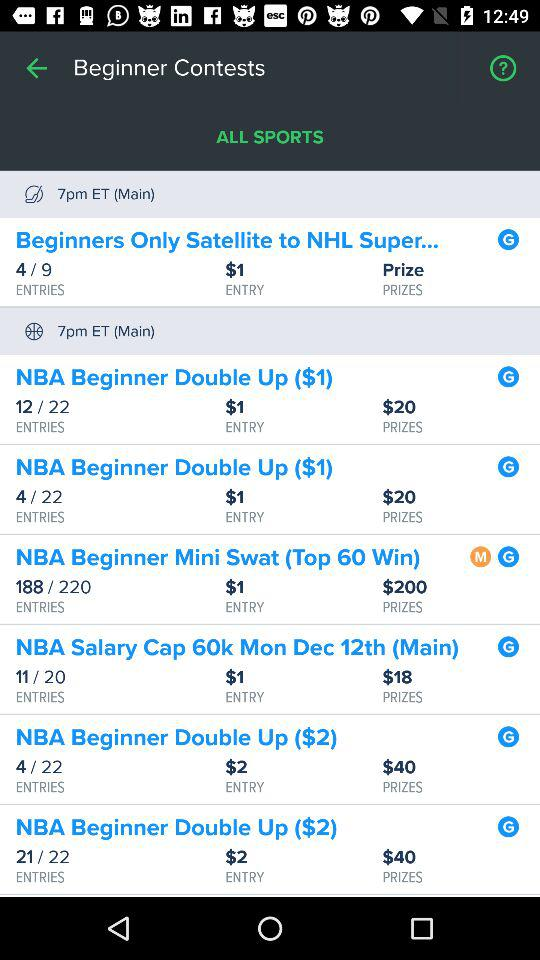What's the entry price for "NBA Beginner Double Up ($1)"? The entry price is $1. 